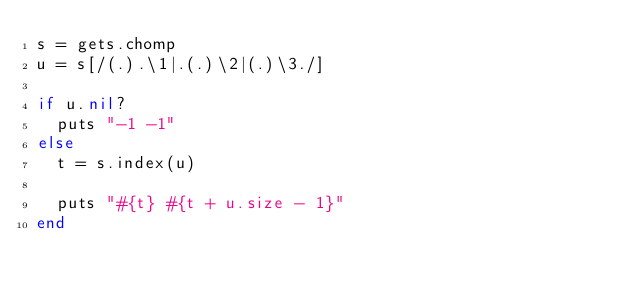Convert code to text. <code><loc_0><loc_0><loc_500><loc_500><_Ruby_>s = gets.chomp
u = s[/(.).\1|.(.)\2|(.)\3./]

if u.nil?
  puts "-1 -1"
else
  t = s.index(u)
  
  puts "#{t} #{t + u.size - 1}"
end</code> 